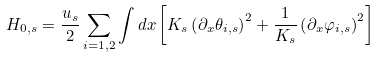<formula> <loc_0><loc_0><loc_500><loc_500>H _ { 0 , s } = \frac { u _ { s } } { 2 } \sum _ { i = 1 , 2 } \int d x \left [ K _ { s } \left ( \partial _ { x } \theta _ { i , s } \right ) ^ { 2 } + \frac { 1 } { K _ { s } } \left ( \partial _ { x } \varphi _ { i , s } \right ) ^ { 2 } \right ]</formula> 